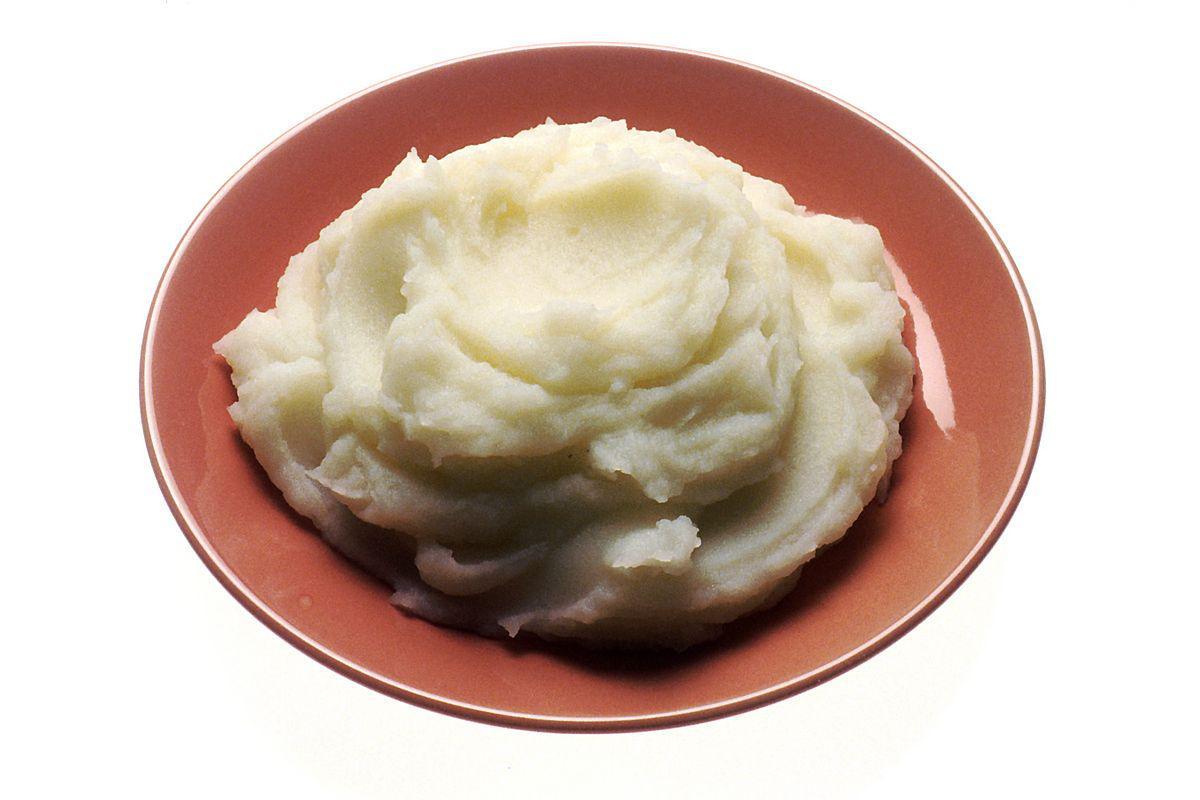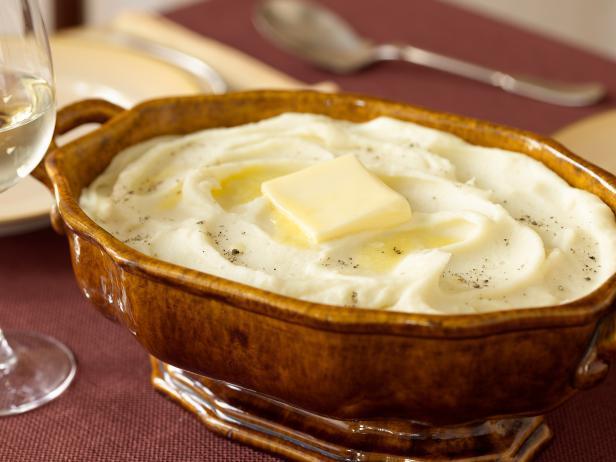The first image is the image on the left, the second image is the image on the right. For the images shown, is this caption "One bowl of mashed potatoes is garnished with a green sprig and the other bowl appears ungarnished." true? Answer yes or no. No. The first image is the image on the left, the second image is the image on the right. Assess this claim about the two images: "At least one of the bowls is white.". Correct or not? Answer yes or no. No. 